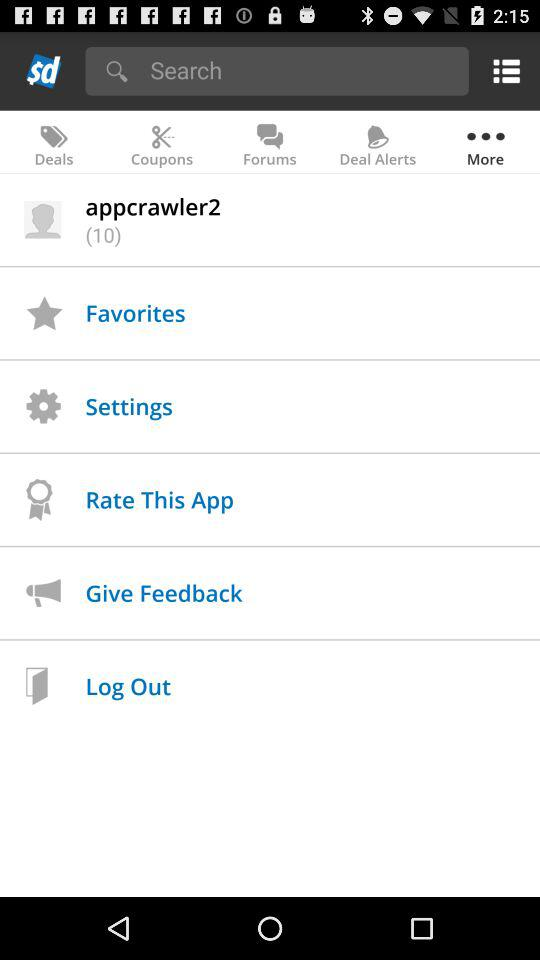Which items are listed in "Favorites"?
When the provided information is insufficient, respond with <no answer>. <no answer> 